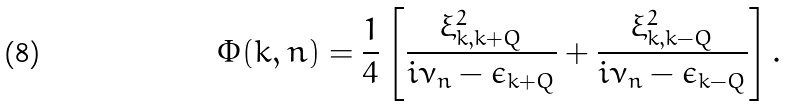Convert formula to latex. <formula><loc_0><loc_0><loc_500><loc_500>\Phi ( k , n ) = \frac { 1 } { 4 } \left [ \frac { \xi _ { k , k + Q } ^ { 2 } } { i \nu _ { n } - \epsilon _ { k + Q } } + \frac { \xi _ { k , k - Q } ^ { 2 } } { i \nu _ { n } - \epsilon _ { k - Q } } \right ] .</formula> 